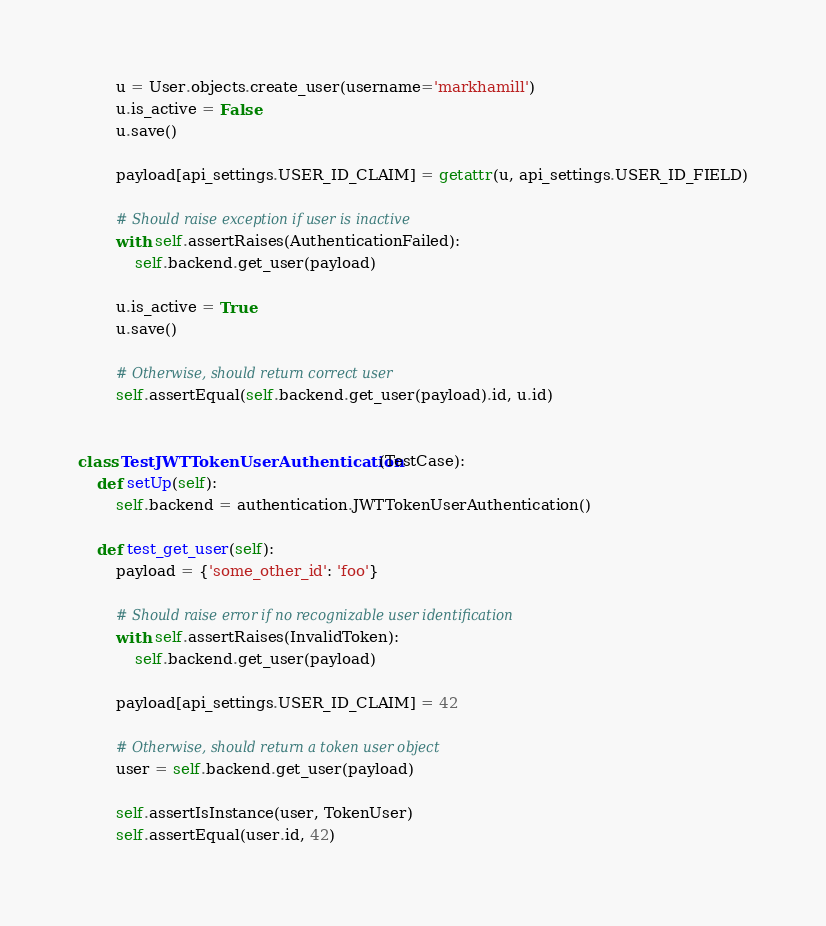<code> <loc_0><loc_0><loc_500><loc_500><_Python_>
        u = User.objects.create_user(username='markhamill')
        u.is_active = False
        u.save()

        payload[api_settings.USER_ID_CLAIM] = getattr(u, api_settings.USER_ID_FIELD)

        # Should raise exception if user is inactive
        with self.assertRaises(AuthenticationFailed):
            self.backend.get_user(payload)

        u.is_active = True
        u.save()

        # Otherwise, should return correct user
        self.assertEqual(self.backend.get_user(payload).id, u.id)


class TestJWTTokenUserAuthentication(TestCase):
    def setUp(self):
        self.backend = authentication.JWTTokenUserAuthentication()

    def test_get_user(self):
        payload = {'some_other_id': 'foo'}

        # Should raise error if no recognizable user identification
        with self.assertRaises(InvalidToken):
            self.backend.get_user(payload)

        payload[api_settings.USER_ID_CLAIM] = 42

        # Otherwise, should return a token user object
        user = self.backend.get_user(payload)

        self.assertIsInstance(user, TokenUser)
        self.assertEqual(user.id, 42)
</code> 